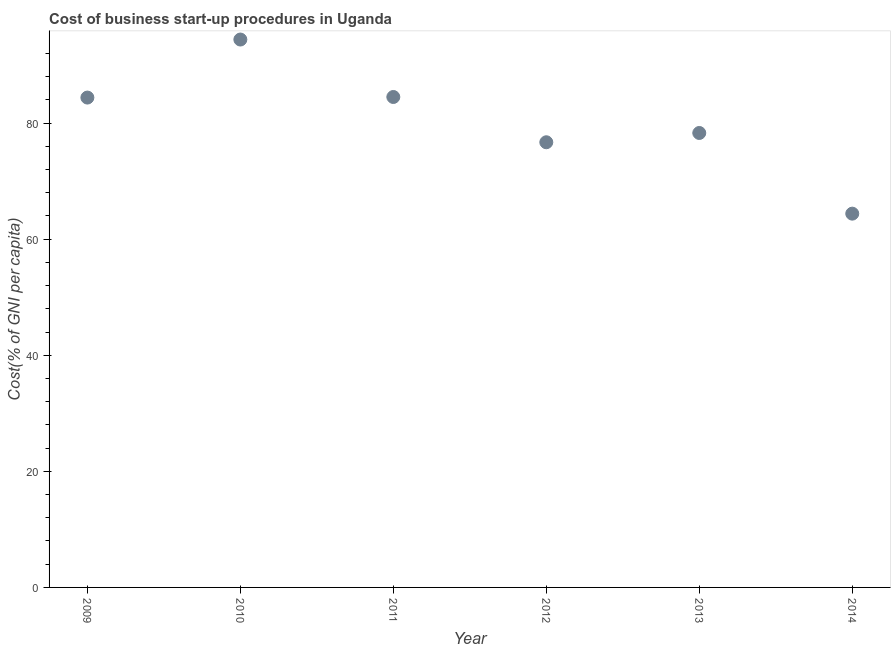What is the cost of business startup procedures in 2012?
Your response must be concise. 76.7. Across all years, what is the maximum cost of business startup procedures?
Your response must be concise. 94.4. Across all years, what is the minimum cost of business startup procedures?
Provide a succinct answer. 64.4. In which year was the cost of business startup procedures maximum?
Make the answer very short. 2010. In which year was the cost of business startup procedures minimum?
Your answer should be compact. 2014. What is the sum of the cost of business startup procedures?
Provide a succinct answer. 482.7. What is the difference between the cost of business startup procedures in 2009 and 2011?
Your response must be concise. -0.1. What is the average cost of business startup procedures per year?
Offer a very short reply. 80.45. What is the median cost of business startup procedures?
Provide a short and direct response. 81.35. In how many years, is the cost of business startup procedures greater than 36 %?
Your answer should be compact. 6. What is the ratio of the cost of business startup procedures in 2012 to that in 2014?
Offer a very short reply. 1.19. Is the cost of business startup procedures in 2009 less than that in 2010?
Provide a short and direct response. Yes. Is the difference between the cost of business startup procedures in 2009 and 2013 greater than the difference between any two years?
Provide a short and direct response. No. What is the difference between the highest and the second highest cost of business startup procedures?
Provide a short and direct response. 9.9. What is the difference between the highest and the lowest cost of business startup procedures?
Offer a terse response. 30. What is the difference between two consecutive major ticks on the Y-axis?
Keep it short and to the point. 20. What is the title of the graph?
Make the answer very short. Cost of business start-up procedures in Uganda. What is the label or title of the X-axis?
Provide a short and direct response. Year. What is the label or title of the Y-axis?
Your answer should be very brief. Cost(% of GNI per capita). What is the Cost(% of GNI per capita) in 2009?
Your response must be concise. 84.4. What is the Cost(% of GNI per capita) in 2010?
Give a very brief answer. 94.4. What is the Cost(% of GNI per capita) in 2011?
Provide a short and direct response. 84.5. What is the Cost(% of GNI per capita) in 2012?
Provide a succinct answer. 76.7. What is the Cost(% of GNI per capita) in 2013?
Offer a terse response. 78.3. What is the Cost(% of GNI per capita) in 2014?
Ensure brevity in your answer.  64.4. What is the difference between the Cost(% of GNI per capita) in 2009 and 2010?
Offer a very short reply. -10. What is the difference between the Cost(% of GNI per capita) in 2009 and 2014?
Offer a terse response. 20. What is the difference between the Cost(% of GNI per capita) in 2010 and 2012?
Keep it short and to the point. 17.7. What is the difference between the Cost(% of GNI per capita) in 2010 and 2014?
Give a very brief answer. 30. What is the difference between the Cost(% of GNI per capita) in 2011 and 2012?
Offer a terse response. 7.8. What is the difference between the Cost(% of GNI per capita) in 2011 and 2013?
Keep it short and to the point. 6.2. What is the difference between the Cost(% of GNI per capita) in 2011 and 2014?
Offer a terse response. 20.1. What is the ratio of the Cost(% of GNI per capita) in 2009 to that in 2010?
Provide a succinct answer. 0.89. What is the ratio of the Cost(% of GNI per capita) in 2009 to that in 2013?
Make the answer very short. 1.08. What is the ratio of the Cost(% of GNI per capita) in 2009 to that in 2014?
Offer a very short reply. 1.31. What is the ratio of the Cost(% of GNI per capita) in 2010 to that in 2011?
Give a very brief answer. 1.12. What is the ratio of the Cost(% of GNI per capita) in 2010 to that in 2012?
Offer a terse response. 1.23. What is the ratio of the Cost(% of GNI per capita) in 2010 to that in 2013?
Offer a very short reply. 1.21. What is the ratio of the Cost(% of GNI per capita) in 2010 to that in 2014?
Give a very brief answer. 1.47. What is the ratio of the Cost(% of GNI per capita) in 2011 to that in 2012?
Ensure brevity in your answer.  1.1. What is the ratio of the Cost(% of GNI per capita) in 2011 to that in 2013?
Ensure brevity in your answer.  1.08. What is the ratio of the Cost(% of GNI per capita) in 2011 to that in 2014?
Your answer should be compact. 1.31. What is the ratio of the Cost(% of GNI per capita) in 2012 to that in 2013?
Give a very brief answer. 0.98. What is the ratio of the Cost(% of GNI per capita) in 2012 to that in 2014?
Give a very brief answer. 1.19. What is the ratio of the Cost(% of GNI per capita) in 2013 to that in 2014?
Offer a terse response. 1.22. 